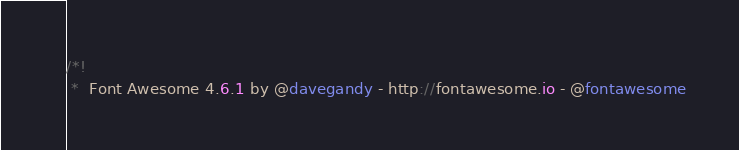<code> <loc_0><loc_0><loc_500><loc_500><_CSS_>/*!
 *  Font Awesome 4.6.1 by @davegandy - http://fontawesome.io - @fontawesome</code> 